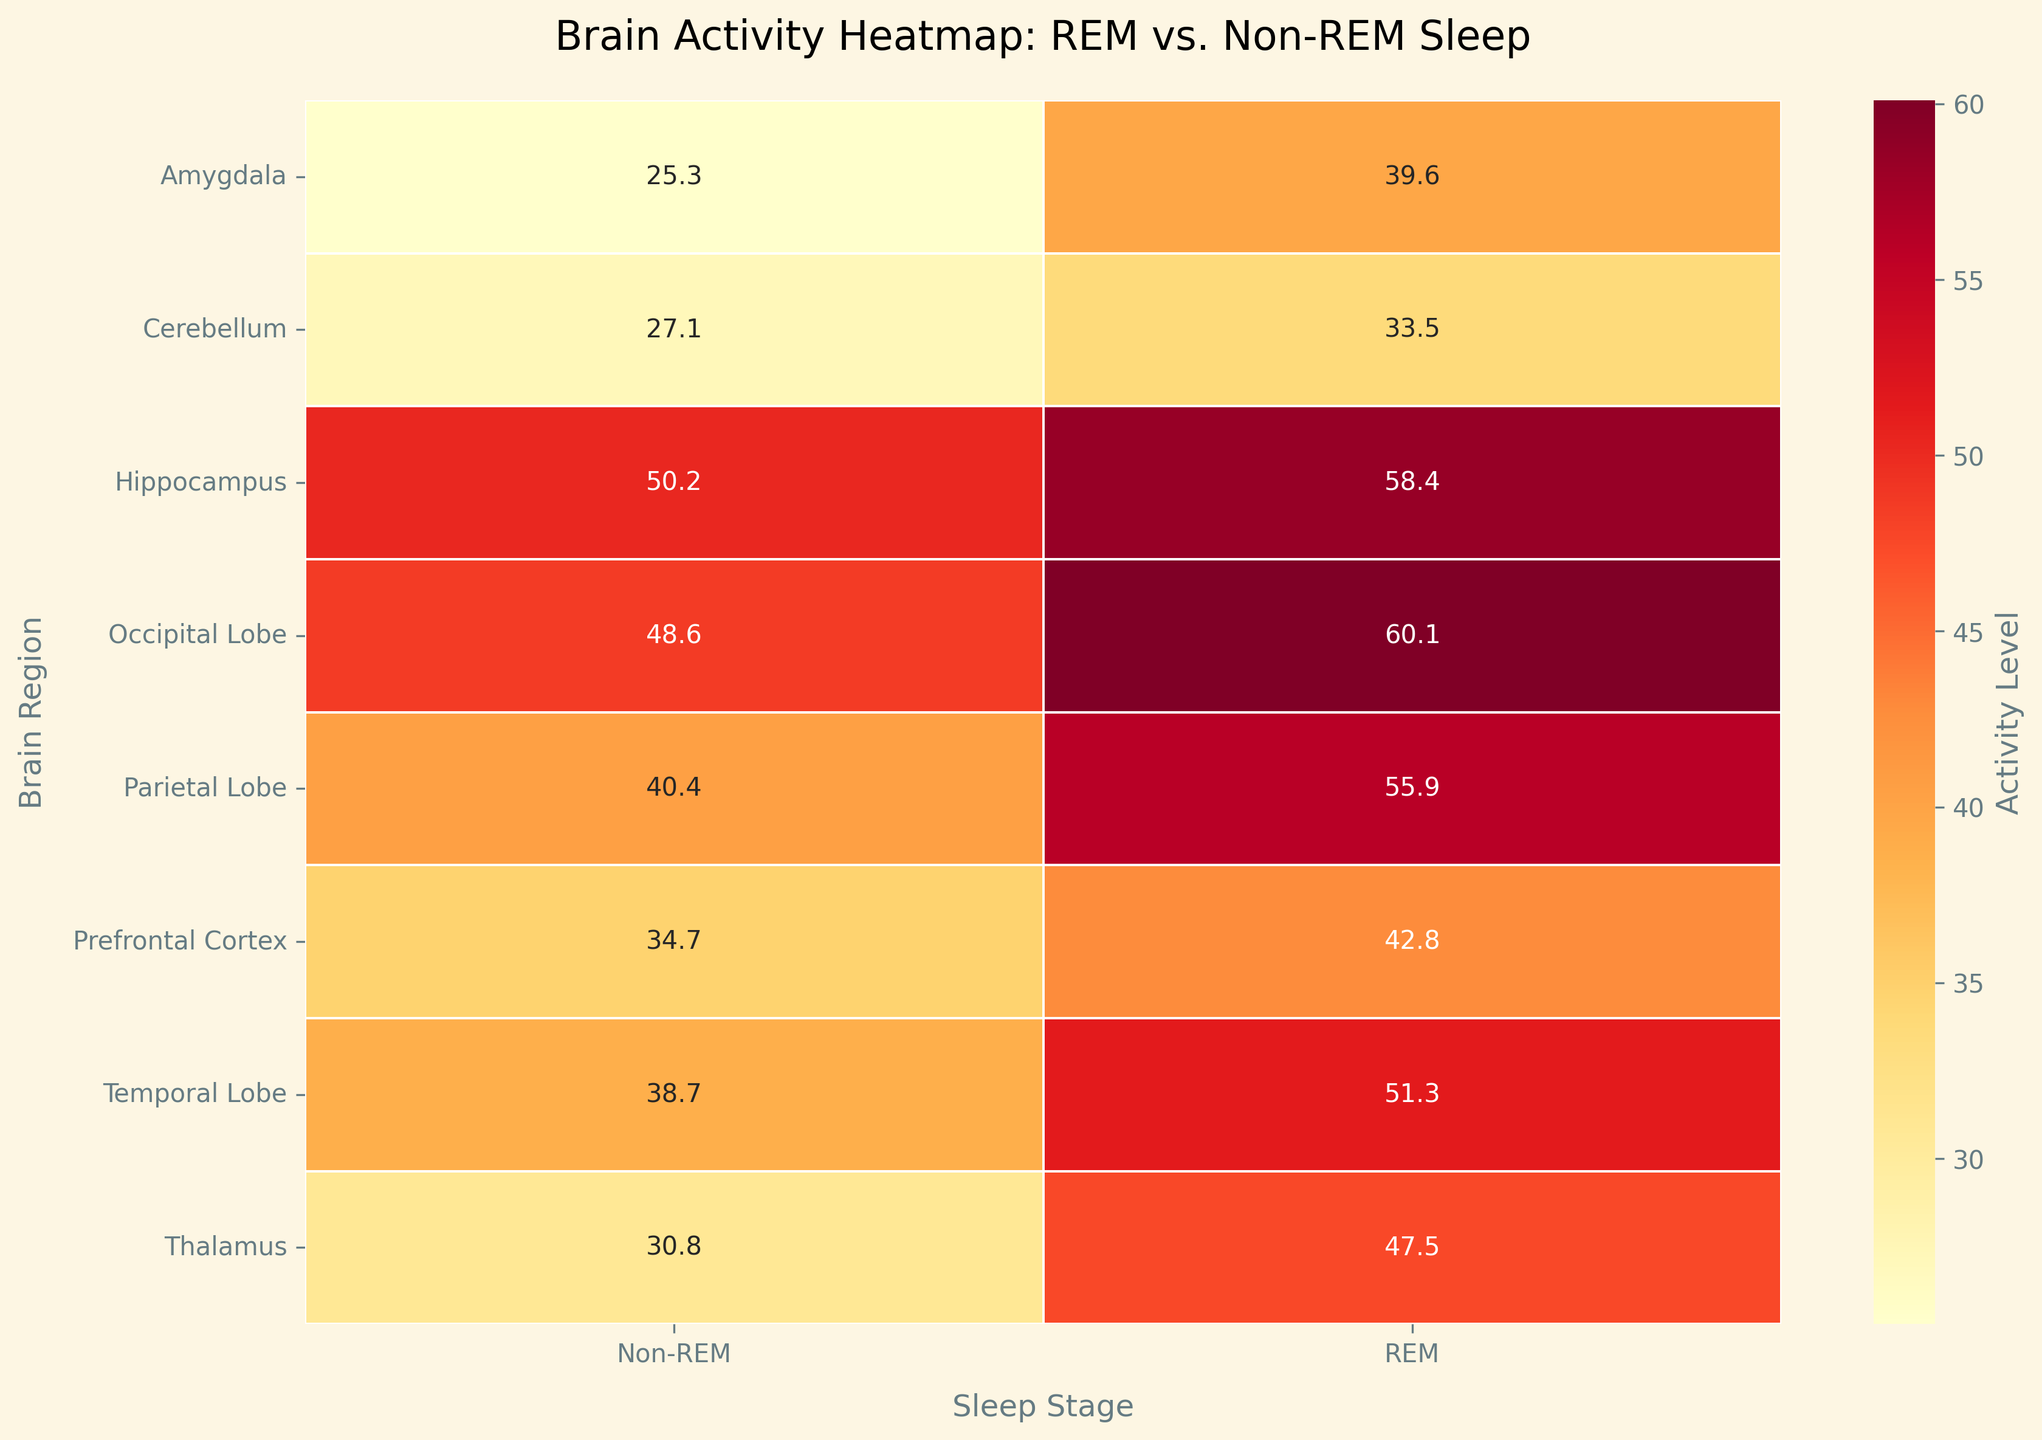What is the title of the heatmap? The title is the most prominent text, generally located at the top center of the figure. It gives a brief description of the figure's content.
Answer: Brain Activity Heatmap: REM vs. Non-REM Sleep Which brain region shows the highest activity level during REM sleep? Identify the cell in the "REM" column with the highest value and find the corresponding row (brain region) for that value.
Answer: Occipital Lobe What are the activity levels in the Prefrontal Cortex for REM and Non-REM sleep? Locate the row corresponding to "Prefrontal Cortex" and observe the values in both the "REM" and "Non-REM" columns.
Answer: REM: 42.8, Non-REM: 34.7 Which sleep stage exhibits higher activity in the Hippocampus? Compare the values in the "REM" and "Non-REM" columns for the row corresponding to "Hippocampus".
Answer: REM How much does the activity level in the Thalamus change from REM to Non-REM sleep? Subtract the Non-REM value from the REM value for the "Thalamus" row.
Answer: 16.7 What is the average activity level across all brain regions during REM sleep? Sum all the values in the "REM" column and divide by the number of brain regions. (42.8 + 58.4 + 39.6 + 47.5 + 60.1 + 55.9 + 51.3 + 33.5) / 8 = (389.1) / 8
Answer: 48.6 Which brain region shows the greatest difference in activity level between REM and Non-REM sleep? Calculate the difference for each brain region and find the region with the largest absolute difference. For example, the difference for the Amygdala is 39.6 - 25.3 = 14.3. Repeat for all regions. Maximum difference is for the Parietal Lobe, which is 55.9 - 40.4 = 15.5.
Answer: Parietal Lobe Is the activity level in the Temporal Lobe higher during REM sleep or Non-REM sleep? Compare the "REM" and "Non-REM" values for the "Temporal Lobe".
Answer: REM What is the median activity level across all brain regions during Non-REM sleep? List all the values in the "Non-REM" column, sort them, and find the middle value. Values: [25.3, 27.1, 30.8, 34.7, 38.7, 40.4, 48.6, 50.2]; median is (38.7 + 40.4) / 2 since it has an even number of data points.
Answer: 39.55 How does the activity level in the Occipital Lobe during REM sleep compare to that in the Parietal Lobe during Non-REM sleep? Compare the values for "Occipital Lobe" under REM and "Parietal Lobe" under Non-REM. Occipital Lobe (REM) is 60.1, and Parietal Lobe (Non-REM) is 40.4.
Answer: Higher 